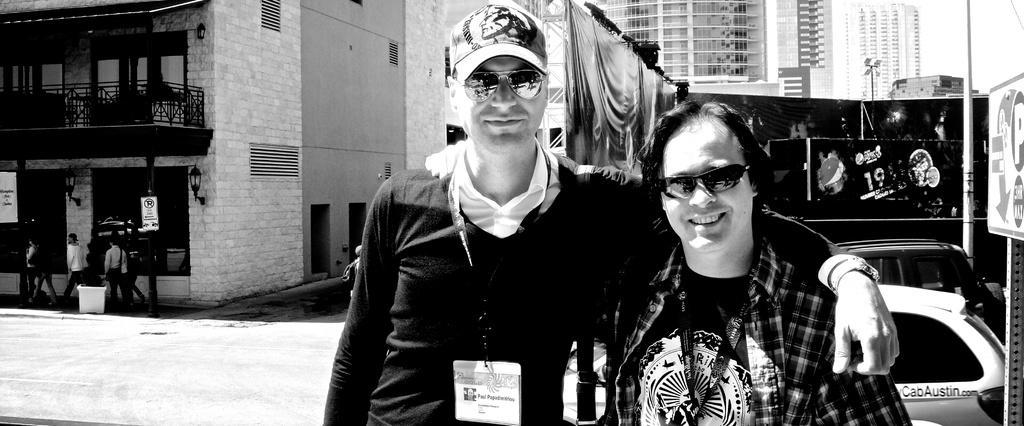Could you give a brief overview of what you see in this image? This image is a black and white image. This image is taken outdoors. In the background there are a few buildings with walls, windows, balconies, railings, roofs and doors. There are a few curtains. There is a pole with a street light. On the left side of the image there are two boards with text on them. A few people are walking on the road there is a dustbin on the floor. On the right side of the image there are a few boards with text on them. There is a pole and two cars are parked on the road. In the middle of the image two men are standing and they are with smiling faces. 